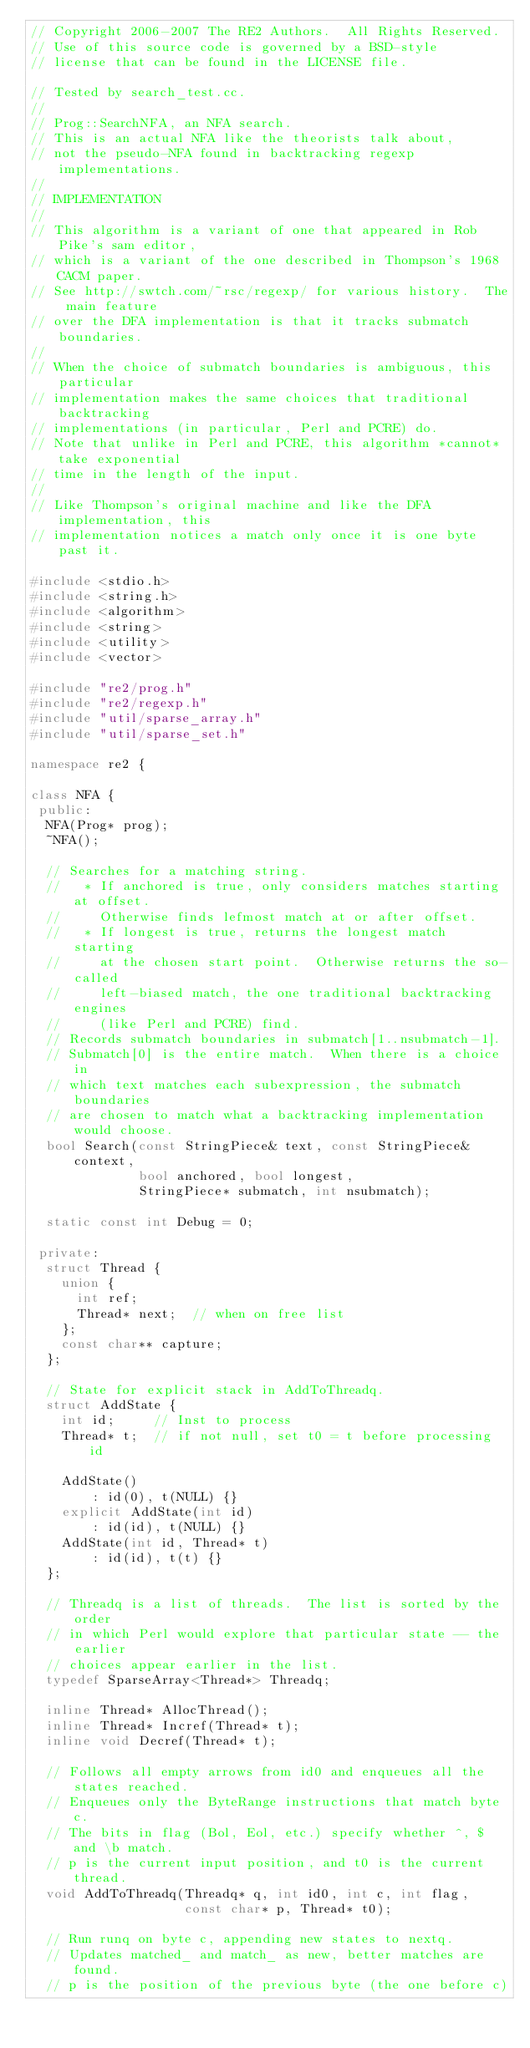Convert code to text. <code><loc_0><loc_0><loc_500><loc_500><_C++_>// Copyright 2006-2007 The RE2 Authors.  All Rights Reserved.
// Use of this source code is governed by a BSD-style
// license that can be found in the LICENSE file.

// Tested by search_test.cc.
//
// Prog::SearchNFA, an NFA search.
// This is an actual NFA like the theorists talk about,
// not the pseudo-NFA found in backtracking regexp implementations.
//
// IMPLEMENTATION
//
// This algorithm is a variant of one that appeared in Rob Pike's sam editor,
// which is a variant of the one described in Thompson's 1968 CACM paper.
// See http://swtch.com/~rsc/regexp/ for various history.  The main feature
// over the DFA implementation is that it tracks submatch boundaries.
//
// When the choice of submatch boundaries is ambiguous, this particular
// implementation makes the same choices that traditional backtracking
// implementations (in particular, Perl and PCRE) do.
// Note that unlike in Perl and PCRE, this algorithm *cannot* take exponential
// time in the length of the input.
//
// Like Thompson's original machine and like the DFA implementation, this
// implementation notices a match only once it is one byte past it.

#include <stdio.h>
#include <string.h>
#include <algorithm>
#include <string>
#include <utility>
#include <vector>

#include "re2/prog.h"
#include "re2/regexp.h"
#include "util/sparse_array.h"
#include "util/sparse_set.h"

namespace re2 {

class NFA {
 public:
  NFA(Prog* prog);
  ~NFA();

  // Searches for a matching string.
  //   * If anchored is true, only considers matches starting at offset.
  //     Otherwise finds lefmost match at or after offset.
  //   * If longest is true, returns the longest match starting
  //     at the chosen start point.  Otherwise returns the so-called
  //     left-biased match, the one traditional backtracking engines
  //     (like Perl and PCRE) find.
  // Records submatch boundaries in submatch[1..nsubmatch-1].
  // Submatch[0] is the entire match.  When there is a choice in
  // which text matches each subexpression, the submatch boundaries
  // are chosen to match what a backtracking implementation would choose.
  bool Search(const StringPiece& text, const StringPiece& context,
              bool anchored, bool longest,
              StringPiece* submatch, int nsubmatch);

  static const int Debug = 0;

 private:
  struct Thread {
    union {
      int ref;
      Thread* next;  // when on free list
    };
    const char** capture;
  };

  // State for explicit stack in AddToThreadq.
  struct AddState {
    int id;     // Inst to process
    Thread* t;  // if not null, set t0 = t before processing id

    AddState()
        : id(0), t(NULL) {}
    explicit AddState(int id)
        : id(id), t(NULL) {}
    AddState(int id, Thread* t)
        : id(id), t(t) {}
  };

  // Threadq is a list of threads.  The list is sorted by the order
  // in which Perl would explore that particular state -- the earlier
  // choices appear earlier in the list.
  typedef SparseArray<Thread*> Threadq;

  inline Thread* AllocThread();
  inline Thread* Incref(Thread* t);
  inline void Decref(Thread* t);

  // Follows all empty arrows from id0 and enqueues all the states reached.
  // Enqueues only the ByteRange instructions that match byte c.
  // The bits in flag (Bol, Eol, etc.) specify whether ^, $ and \b match.
  // p is the current input position, and t0 is the current thread.
  void AddToThreadq(Threadq* q, int id0, int c, int flag,
                    const char* p, Thread* t0);

  // Run runq on byte c, appending new states to nextq.
  // Updates matched_ and match_ as new, better matches are found.
  // p is the position of the previous byte (the one before c)</code> 